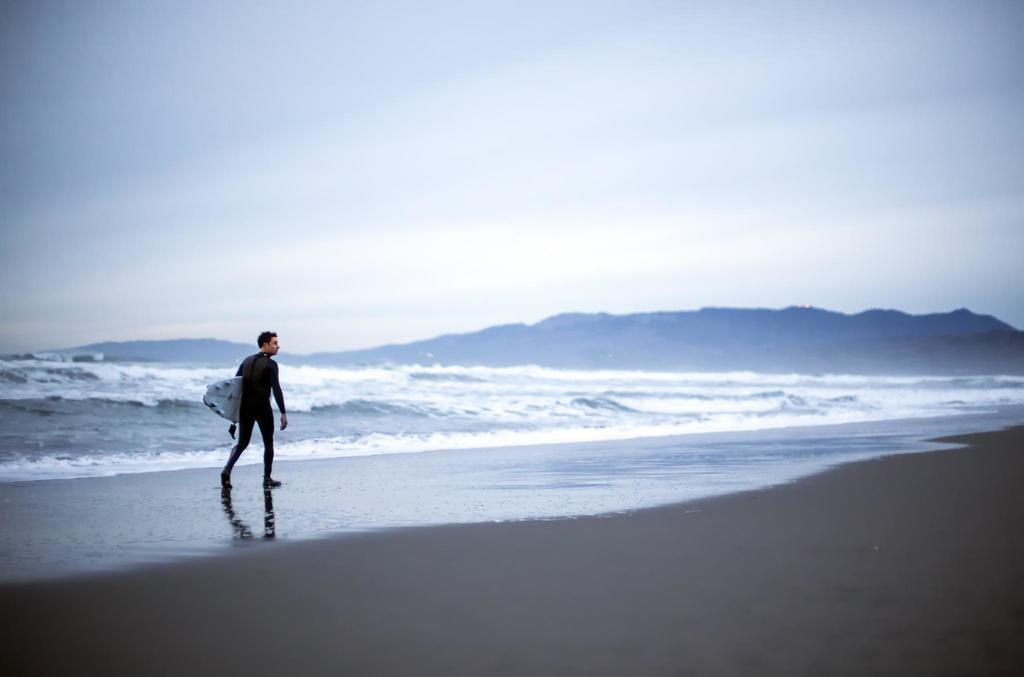Could you give a brief overview of what you see in this image? In this image we can see a person standing on the ground holding a surfboard in his hand. In the background we can see water ,mountains and sky. 